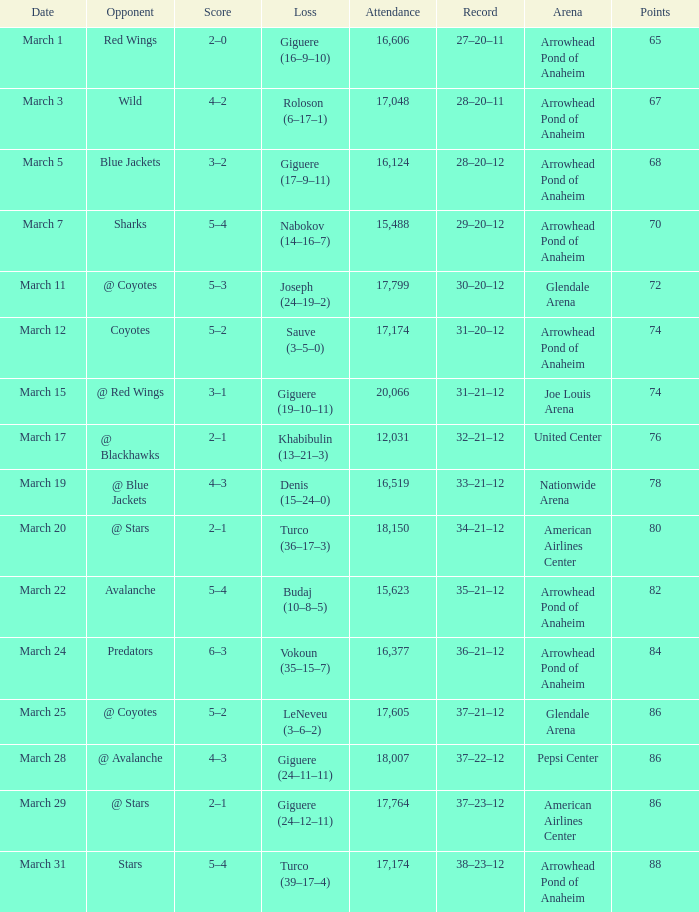What is the Score of the game on March 19? 4–3. 